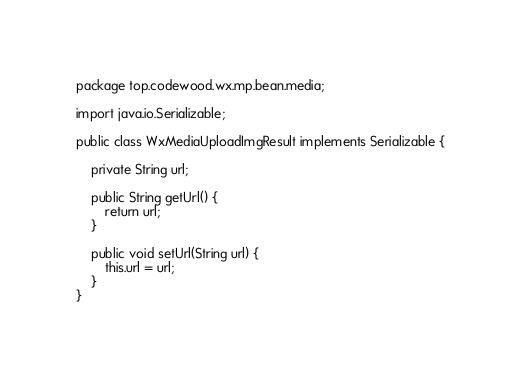<code> <loc_0><loc_0><loc_500><loc_500><_Java_>package top.codewood.wx.mp.bean.media;

import java.io.Serializable;

public class WxMediaUploadImgResult implements Serializable {

    private String url;

    public String getUrl() {
        return url;
    }

    public void setUrl(String url) {
        this.url = url;
    }
}
</code> 